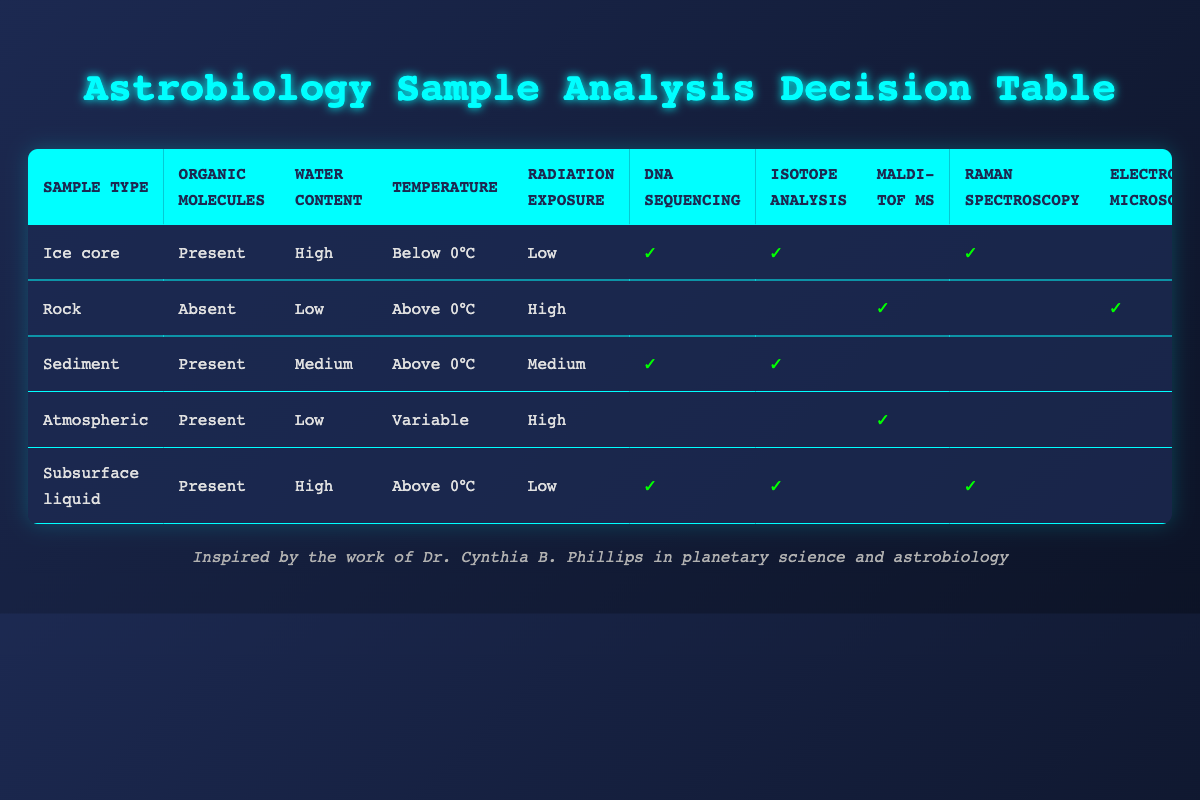What actions should be taken for an ice core sample? The table indicates that for an ice core sample, the actions to be taken are "Perform DNA sequencing", "Conduct isotope analysis", and "Use Raman spectroscopy". These are directly listed in the row corresponding to the ice core sample type.
Answer: Perform DNA sequencing, Conduct isotope analysis, Use Raman spectroscopy Is gas chromatography applicable for rock samples? Referring to the row for the rock sample, gas chromatography is not checked under actions. Therefore, it is not applicable for rock samples.
Answer: No Which sample type requires both "Perform DNA sequencing" and "Conduct isotope analysis"? To find this, we look for samples where both "Perform DNA sequencing" and "Conduct isotope analysis" are checked. There are two sample types that meet this criterion: "Ice core" and "Subsurface liquid".
Answer: Ice core, Subsurface liquid What is the maximum water content for samples that allow MALDI-TOF mass spectrometry? The table shows that "MALDI-TOF mass spectrometry" is applied to "Rock" with low water content and "Atmospheric" with low water content as well. Therefore, the maximum water content allowing this action is "Low".
Answer: Low How many actions are applicable for the subsurface liquid sample? The subsurface liquid sample has "Perform DNA sequencing", "Conduct isotope analysis", "Use Raman spectroscopy", and "Perform gas chromatography". Counting these checked actions gives us four actions.
Answer: 4 Are there any samples where both organic molecules are present and radiation exposure is low? The ice core and subsurface liquid samples meet these criteria as both have "Present" for organic molecules and "Low" for radiation exposure. Therefore, yes, there are such samples.
Answer: Yes What action is taken only for sediment samples? Looking at the actions for sediment samples, the specific action that doesn't appear for any other sample type is "Perform gas chromatography". Therefore, this is the only action taken solely for sediment samples.
Answer: Perform gas chromatography Which sample type has the highest water content along with the most actions? Analyzing the table, the subsurface liquid sample has "High" water content and has four actions: "Perform DNA sequencing", "Conduct isotope analysis", "Use Raman spectroscopy", and "Perform gas chromatography". No other sample type meets both criteria of high water content and the number of actions.
Answer: Subsurface liquid Is it true that all samples with "Present" organic molecules will have DNA sequencing performed? Examining each sample with present organic molecules, both ice core and subsurface liquid samples have DNA sequencing, but atmospheric samples do not have it performed. Thus, the statement is false.
Answer: No 